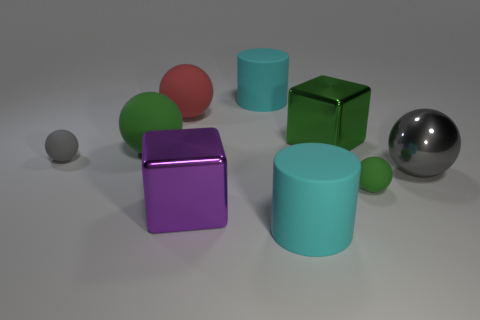How many green spheres must be subtracted to get 1 green spheres? 1 Subtract all green balls. How many balls are left? 3 Subtract all metallic spheres. How many spheres are left? 4 Subtract 1 spheres. How many spheres are left? 4 Subtract all purple cylinders. How many red spheres are left? 1 Subtract all small gray rubber objects. Subtract all matte balls. How many objects are left? 4 Add 5 gray rubber objects. How many gray rubber objects are left? 6 Add 7 tiny red matte things. How many tiny red matte things exist? 7 Subtract 0 brown cubes. How many objects are left? 9 Subtract all blocks. How many objects are left? 7 